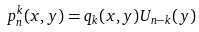Convert formula to latex. <formula><loc_0><loc_0><loc_500><loc_500>p _ { n } ^ { k } ( x , y ) = q _ { k } ( x , y ) U _ { n - k } ( y )</formula> 